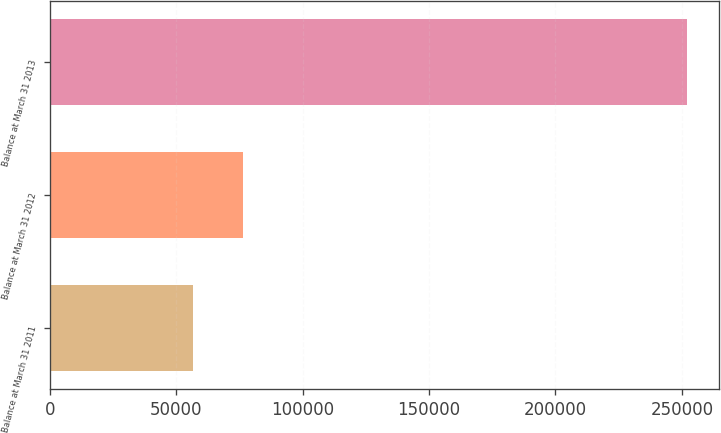Convert chart to OTSL. <chart><loc_0><loc_0><loc_500><loc_500><bar_chart><fcel>Balance at March 31 2011<fcel>Balance at March 31 2012<fcel>Balance at March 31 2013<nl><fcel>56818<fcel>76351<fcel>252148<nl></chart> 